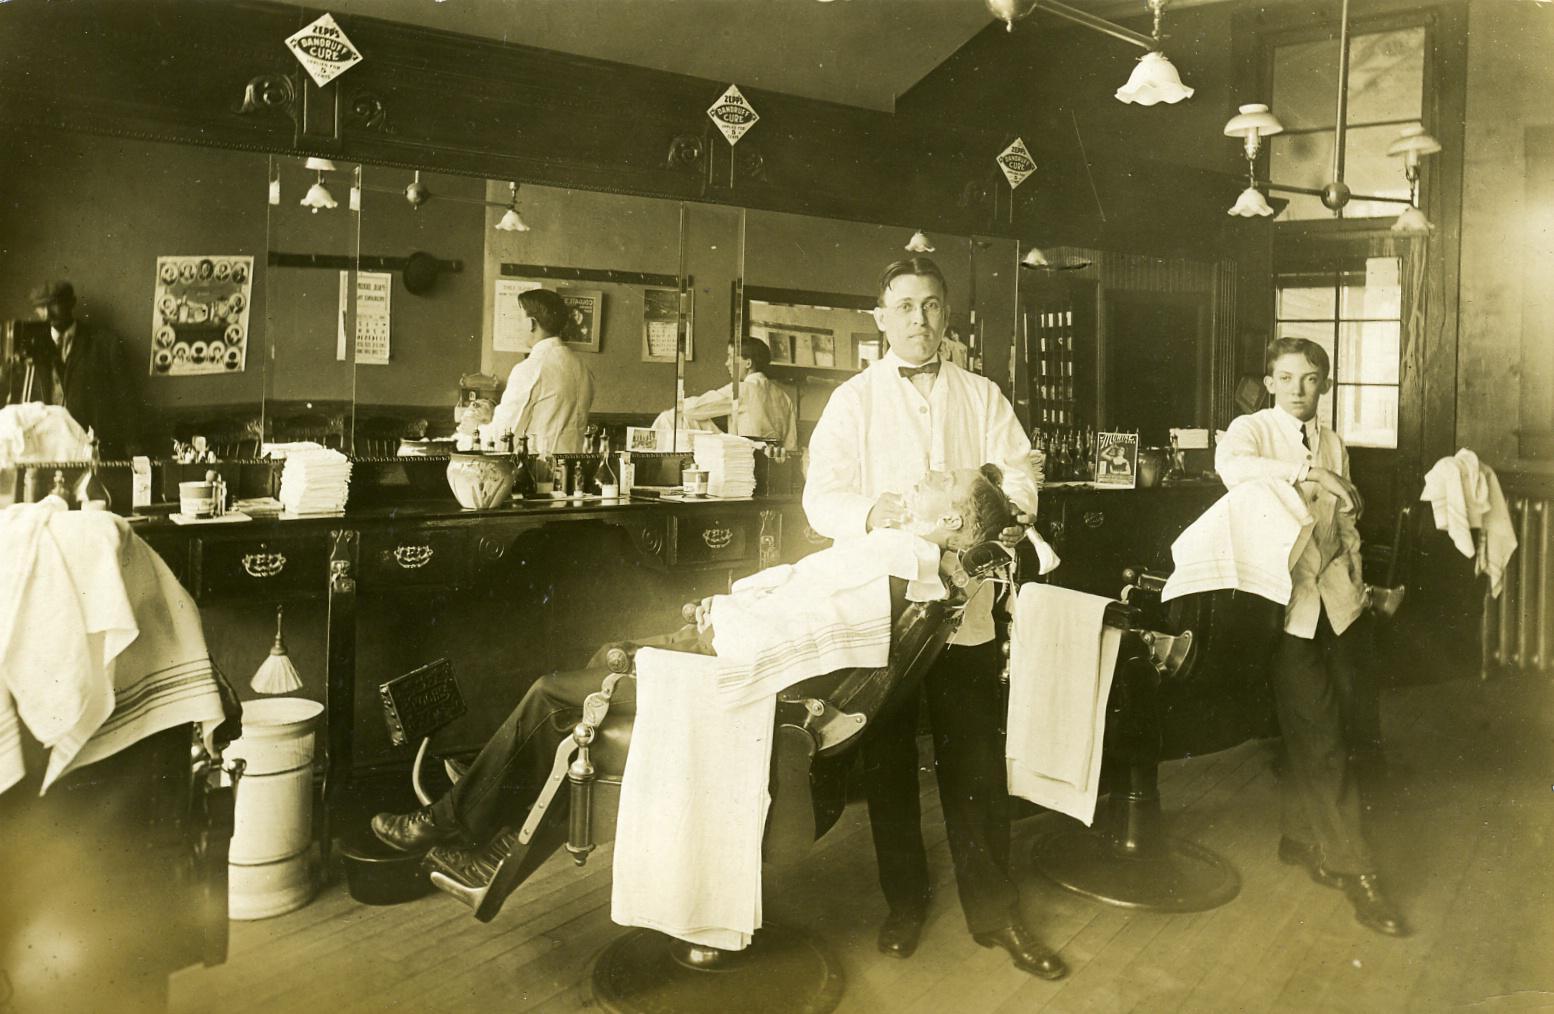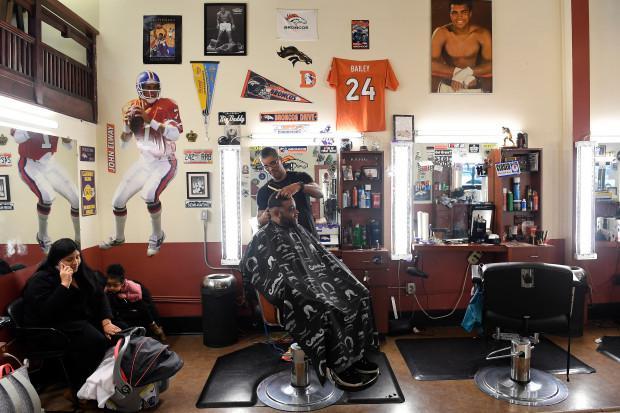The first image is the image on the left, the second image is the image on the right. Given the left and right images, does the statement "In one image, one barber has a customer in his chair and one does not." hold true? Answer yes or no. Yes. The first image is the image on the left, the second image is the image on the right. Evaluate the accuracy of this statement regarding the images: "THere are exactly two people in the image on the left.". Is it true? Answer yes or no. Yes. 